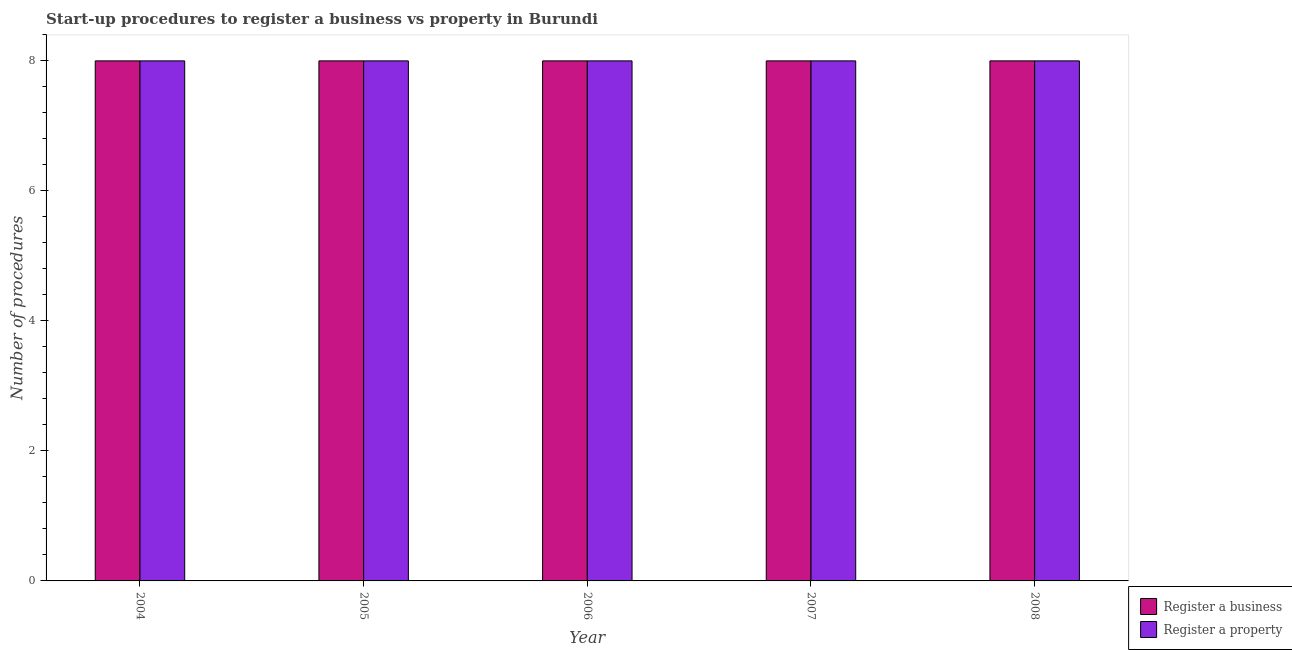How many groups of bars are there?
Provide a succinct answer. 5. Are the number of bars per tick equal to the number of legend labels?
Make the answer very short. Yes. How many bars are there on the 5th tick from the left?
Provide a succinct answer. 2. What is the label of the 4th group of bars from the left?
Offer a terse response. 2007. In how many cases, is the number of bars for a given year not equal to the number of legend labels?
Your answer should be very brief. 0. What is the number of procedures to register a business in 2007?
Ensure brevity in your answer.  8. Across all years, what is the maximum number of procedures to register a business?
Provide a short and direct response. 8. Across all years, what is the minimum number of procedures to register a business?
Your answer should be very brief. 8. In which year was the number of procedures to register a property maximum?
Ensure brevity in your answer.  2004. In which year was the number of procedures to register a property minimum?
Ensure brevity in your answer.  2004. What is the total number of procedures to register a business in the graph?
Your answer should be very brief. 40. What is the average number of procedures to register a business per year?
Your answer should be very brief. 8. In how many years, is the number of procedures to register a business greater than 4?
Provide a succinct answer. 5. Is the difference between the number of procedures to register a property in 2004 and 2008 greater than the difference between the number of procedures to register a business in 2004 and 2008?
Provide a succinct answer. No. What is the difference between the highest and the second highest number of procedures to register a business?
Ensure brevity in your answer.  0. What is the difference between the highest and the lowest number of procedures to register a business?
Keep it short and to the point. 0. Is the sum of the number of procedures to register a business in 2007 and 2008 greater than the maximum number of procedures to register a property across all years?
Provide a short and direct response. Yes. What does the 1st bar from the left in 2006 represents?
Offer a very short reply. Register a business. What does the 1st bar from the right in 2007 represents?
Give a very brief answer. Register a property. How many years are there in the graph?
Make the answer very short. 5. What is the difference between two consecutive major ticks on the Y-axis?
Offer a very short reply. 2. Are the values on the major ticks of Y-axis written in scientific E-notation?
Your answer should be very brief. No. Does the graph contain any zero values?
Your response must be concise. No. Does the graph contain grids?
Your answer should be very brief. No. Where does the legend appear in the graph?
Provide a succinct answer. Bottom right. How many legend labels are there?
Provide a succinct answer. 2. What is the title of the graph?
Offer a terse response. Start-up procedures to register a business vs property in Burundi. What is the label or title of the X-axis?
Offer a very short reply. Year. What is the label or title of the Y-axis?
Make the answer very short. Number of procedures. What is the Number of procedures of Register a property in 2004?
Offer a terse response. 8. What is the Number of procedures of Register a property in 2005?
Give a very brief answer. 8. What is the Number of procedures of Register a business in 2006?
Ensure brevity in your answer.  8. What is the Number of procedures in Register a business in 2007?
Your response must be concise. 8. What is the Number of procedures of Register a property in 2007?
Your response must be concise. 8. Across all years, what is the maximum Number of procedures of Register a business?
Give a very brief answer. 8. Across all years, what is the minimum Number of procedures in Register a business?
Your response must be concise. 8. What is the total Number of procedures in Register a business in the graph?
Your answer should be compact. 40. What is the total Number of procedures of Register a property in the graph?
Keep it short and to the point. 40. What is the difference between the Number of procedures in Register a business in 2004 and that in 2006?
Offer a terse response. 0. What is the difference between the Number of procedures in Register a property in 2004 and that in 2006?
Keep it short and to the point. 0. What is the difference between the Number of procedures of Register a property in 2004 and that in 2008?
Ensure brevity in your answer.  0. What is the difference between the Number of procedures in Register a property in 2005 and that in 2006?
Keep it short and to the point. 0. What is the difference between the Number of procedures in Register a business in 2005 and that in 2007?
Offer a very short reply. 0. What is the difference between the Number of procedures in Register a property in 2006 and that in 2007?
Offer a terse response. 0. What is the difference between the Number of procedures of Register a business in 2006 and that in 2008?
Your answer should be very brief. 0. What is the difference between the Number of procedures of Register a property in 2006 and that in 2008?
Offer a very short reply. 0. What is the difference between the Number of procedures in Register a business in 2004 and the Number of procedures in Register a property in 2006?
Offer a very short reply. 0. What is the difference between the Number of procedures of Register a business in 2004 and the Number of procedures of Register a property in 2007?
Keep it short and to the point. 0. What is the difference between the Number of procedures of Register a business in 2005 and the Number of procedures of Register a property in 2006?
Your response must be concise. 0. What is the difference between the Number of procedures of Register a business in 2006 and the Number of procedures of Register a property in 2008?
Your response must be concise. 0. What is the average Number of procedures of Register a business per year?
Provide a short and direct response. 8. What is the average Number of procedures in Register a property per year?
Your answer should be compact. 8. What is the ratio of the Number of procedures in Register a property in 2004 to that in 2005?
Offer a terse response. 1. What is the ratio of the Number of procedures in Register a business in 2004 to that in 2007?
Your answer should be compact. 1. What is the ratio of the Number of procedures in Register a business in 2004 to that in 2008?
Provide a short and direct response. 1. What is the ratio of the Number of procedures of Register a property in 2005 to that in 2006?
Offer a terse response. 1. What is the ratio of the Number of procedures of Register a business in 2005 to that in 2008?
Your answer should be compact. 1. What is the ratio of the Number of procedures in Register a property in 2007 to that in 2008?
Your answer should be very brief. 1. 